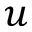<formula> <loc_0><loc_0><loc_500><loc_500>u</formula> 